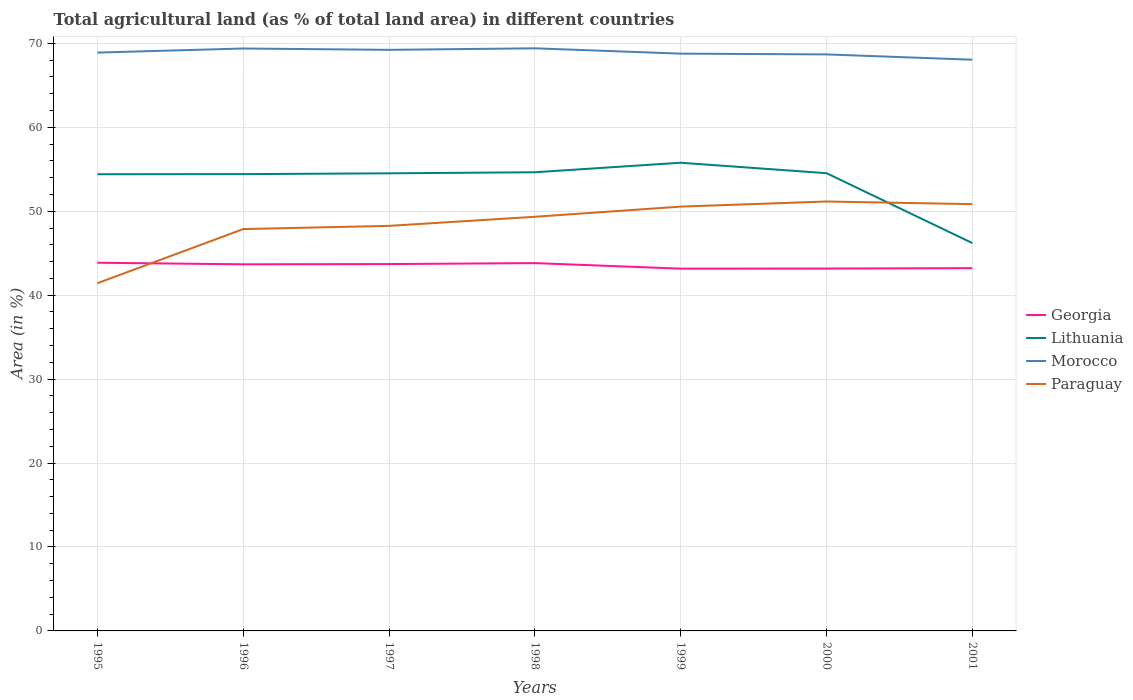How many different coloured lines are there?
Give a very brief answer. 4. Does the line corresponding to Morocco intersect with the line corresponding to Paraguay?
Your response must be concise. No. Is the number of lines equal to the number of legend labels?
Make the answer very short. Yes. Across all years, what is the maximum percentage of agricultural land in Paraguay?
Ensure brevity in your answer.  41.42. What is the total percentage of agricultural land in Paraguay in the graph?
Offer a very short reply. -2.59. What is the difference between the highest and the second highest percentage of agricultural land in Lithuania?
Your answer should be compact. 9.57. What is the difference between the highest and the lowest percentage of agricultural land in Paraguay?
Make the answer very short. 4. Is the percentage of agricultural land in Lithuania strictly greater than the percentage of agricultural land in Morocco over the years?
Your response must be concise. Yes. Does the graph contain any zero values?
Your answer should be very brief. No. What is the title of the graph?
Keep it short and to the point. Total agricultural land (as % of total land area) in different countries. Does "Sub-Saharan Africa (developing only)" appear as one of the legend labels in the graph?
Offer a terse response. No. What is the label or title of the Y-axis?
Offer a very short reply. Area (in %). What is the Area (in %) of Georgia in 1995?
Provide a short and direct response. 43.86. What is the Area (in %) of Lithuania in 1995?
Keep it short and to the point. 54.4. What is the Area (in %) of Morocco in 1995?
Your response must be concise. 68.9. What is the Area (in %) in Paraguay in 1995?
Make the answer very short. 41.42. What is the Area (in %) in Georgia in 1996?
Offer a terse response. 43.68. What is the Area (in %) in Lithuania in 1996?
Offer a terse response. 54.42. What is the Area (in %) of Morocco in 1996?
Your answer should be compact. 69.38. What is the Area (in %) of Paraguay in 1996?
Make the answer very short. 47.88. What is the Area (in %) of Georgia in 1997?
Provide a short and direct response. 43.7. What is the Area (in %) of Lithuania in 1997?
Provide a succinct answer. 54.51. What is the Area (in %) of Morocco in 1997?
Provide a short and direct response. 69.22. What is the Area (in %) in Paraguay in 1997?
Give a very brief answer. 48.25. What is the Area (in %) of Georgia in 1998?
Offer a very short reply. 43.82. What is the Area (in %) in Lithuania in 1998?
Your answer should be very brief. 54.64. What is the Area (in %) in Morocco in 1998?
Provide a succinct answer. 69.41. What is the Area (in %) in Paraguay in 1998?
Offer a terse response. 49.34. What is the Area (in %) of Georgia in 1999?
Keep it short and to the point. 43.16. What is the Area (in %) in Lithuania in 1999?
Provide a succinct answer. 55.78. What is the Area (in %) in Morocco in 1999?
Make the answer very short. 68.77. What is the Area (in %) of Paraguay in 1999?
Provide a succinct answer. 50.55. What is the Area (in %) in Georgia in 2000?
Make the answer very short. 43.17. What is the Area (in %) in Lithuania in 2000?
Your answer should be compact. 54.53. What is the Area (in %) in Morocco in 2000?
Your response must be concise. 68.68. What is the Area (in %) in Paraguay in 2000?
Offer a terse response. 51.16. What is the Area (in %) in Georgia in 2001?
Ensure brevity in your answer.  43.21. What is the Area (in %) of Lithuania in 2001?
Ensure brevity in your answer.  46.2. What is the Area (in %) of Morocco in 2001?
Your response must be concise. 68.05. What is the Area (in %) in Paraguay in 2001?
Make the answer very short. 50.84. Across all years, what is the maximum Area (in %) in Georgia?
Keep it short and to the point. 43.86. Across all years, what is the maximum Area (in %) of Lithuania?
Offer a terse response. 55.78. Across all years, what is the maximum Area (in %) of Morocco?
Your response must be concise. 69.41. Across all years, what is the maximum Area (in %) of Paraguay?
Your answer should be compact. 51.16. Across all years, what is the minimum Area (in %) in Georgia?
Make the answer very short. 43.16. Across all years, what is the minimum Area (in %) of Lithuania?
Your response must be concise. 46.2. Across all years, what is the minimum Area (in %) of Morocco?
Provide a succinct answer. 68.05. Across all years, what is the minimum Area (in %) in Paraguay?
Provide a short and direct response. 41.42. What is the total Area (in %) of Georgia in the graph?
Provide a succinct answer. 304.61. What is the total Area (in %) of Lithuania in the graph?
Offer a terse response. 374.49. What is the total Area (in %) in Morocco in the graph?
Offer a terse response. 482.41. What is the total Area (in %) in Paraguay in the graph?
Keep it short and to the point. 339.44. What is the difference between the Area (in %) in Georgia in 1995 and that in 1996?
Your answer should be very brief. 0.19. What is the difference between the Area (in %) of Lithuania in 1995 and that in 1996?
Your response must be concise. -0.02. What is the difference between the Area (in %) in Morocco in 1995 and that in 1996?
Your response must be concise. -0.49. What is the difference between the Area (in %) of Paraguay in 1995 and that in 1996?
Make the answer very short. -6.45. What is the difference between the Area (in %) in Georgia in 1995 and that in 1997?
Offer a terse response. 0.16. What is the difference between the Area (in %) in Lithuania in 1995 and that in 1997?
Give a very brief answer. -0.11. What is the difference between the Area (in %) of Morocco in 1995 and that in 1997?
Your answer should be compact. -0.33. What is the difference between the Area (in %) in Paraguay in 1995 and that in 1997?
Offer a very short reply. -6.83. What is the difference between the Area (in %) of Georgia in 1995 and that in 1998?
Provide a short and direct response. 0.04. What is the difference between the Area (in %) in Lithuania in 1995 and that in 1998?
Your response must be concise. -0.24. What is the difference between the Area (in %) of Morocco in 1995 and that in 1998?
Your answer should be very brief. -0.51. What is the difference between the Area (in %) in Paraguay in 1995 and that in 1998?
Ensure brevity in your answer.  -7.91. What is the difference between the Area (in %) in Georgia in 1995 and that in 1999?
Your answer should be very brief. 0.71. What is the difference between the Area (in %) in Lithuania in 1995 and that in 1999?
Make the answer very short. -1.37. What is the difference between the Area (in %) of Morocco in 1995 and that in 1999?
Keep it short and to the point. 0.13. What is the difference between the Area (in %) of Paraguay in 1995 and that in 1999?
Your response must be concise. -9.12. What is the difference between the Area (in %) of Georgia in 1995 and that in 2000?
Provide a succinct answer. 0.69. What is the difference between the Area (in %) in Lithuania in 1995 and that in 2000?
Ensure brevity in your answer.  -0.13. What is the difference between the Area (in %) in Morocco in 1995 and that in 2000?
Give a very brief answer. 0.22. What is the difference between the Area (in %) in Paraguay in 1995 and that in 2000?
Offer a terse response. -9.73. What is the difference between the Area (in %) in Georgia in 1995 and that in 2001?
Your response must be concise. 0.65. What is the difference between the Area (in %) in Lithuania in 1995 and that in 2001?
Your answer should be compact. 8.2. What is the difference between the Area (in %) of Morocco in 1995 and that in 2001?
Your answer should be compact. 0.85. What is the difference between the Area (in %) in Paraguay in 1995 and that in 2001?
Ensure brevity in your answer.  -9.42. What is the difference between the Area (in %) of Georgia in 1996 and that in 1997?
Your response must be concise. -0.03. What is the difference between the Area (in %) in Lithuania in 1996 and that in 1997?
Provide a short and direct response. -0.1. What is the difference between the Area (in %) in Morocco in 1996 and that in 1997?
Make the answer very short. 0.16. What is the difference between the Area (in %) in Paraguay in 1996 and that in 1997?
Provide a succinct answer. -0.38. What is the difference between the Area (in %) of Georgia in 1996 and that in 1998?
Your answer should be compact. -0.14. What is the difference between the Area (in %) of Lithuania in 1996 and that in 1998?
Your response must be concise. -0.22. What is the difference between the Area (in %) in Morocco in 1996 and that in 1998?
Offer a terse response. -0.02. What is the difference between the Area (in %) of Paraguay in 1996 and that in 1998?
Give a very brief answer. -1.46. What is the difference between the Area (in %) in Georgia in 1996 and that in 1999?
Your response must be concise. 0.52. What is the difference between the Area (in %) in Lithuania in 1996 and that in 1999?
Offer a very short reply. -1.36. What is the difference between the Area (in %) of Morocco in 1996 and that in 1999?
Ensure brevity in your answer.  0.61. What is the difference between the Area (in %) in Paraguay in 1996 and that in 1999?
Keep it short and to the point. -2.67. What is the difference between the Area (in %) in Georgia in 1996 and that in 2000?
Offer a very short reply. 0.5. What is the difference between the Area (in %) of Lithuania in 1996 and that in 2000?
Provide a succinct answer. -0.11. What is the difference between the Area (in %) of Morocco in 1996 and that in 2000?
Provide a succinct answer. 0.7. What is the difference between the Area (in %) in Paraguay in 1996 and that in 2000?
Offer a very short reply. -3.28. What is the difference between the Area (in %) in Georgia in 1996 and that in 2001?
Give a very brief answer. 0.46. What is the difference between the Area (in %) in Lithuania in 1996 and that in 2001?
Make the answer very short. 8.22. What is the difference between the Area (in %) of Morocco in 1996 and that in 2001?
Provide a short and direct response. 1.34. What is the difference between the Area (in %) of Paraguay in 1996 and that in 2001?
Give a very brief answer. -2.97. What is the difference between the Area (in %) in Georgia in 1997 and that in 1998?
Your response must be concise. -0.12. What is the difference between the Area (in %) of Lithuania in 1997 and that in 1998?
Your answer should be very brief. -0.13. What is the difference between the Area (in %) of Morocco in 1997 and that in 1998?
Offer a terse response. -0.18. What is the difference between the Area (in %) of Paraguay in 1997 and that in 1998?
Make the answer very short. -1.08. What is the difference between the Area (in %) in Georgia in 1997 and that in 1999?
Provide a short and direct response. 0.55. What is the difference between the Area (in %) in Lithuania in 1997 and that in 1999?
Keep it short and to the point. -1.26. What is the difference between the Area (in %) in Morocco in 1997 and that in 1999?
Your answer should be very brief. 0.45. What is the difference between the Area (in %) of Paraguay in 1997 and that in 1999?
Provide a succinct answer. -2.3. What is the difference between the Area (in %) in Georgia in 1997 and that in 2000?
Your answer should be very brief. 0.53. What is the difference between the Area (in %) of Lithuania in 1997 and that in 2000?
Make the answer very short. -0.02. What is the difference between the Area (in %) in Morocco in 1997 and that in 2000?
Ensure brevity in your answer.  0.54. What is the difference between the Area (in %) in Paraguay in 1997 and that in 2000?
Provide a succinct answer. -2.9. What is the difference between the Area (in %) in Georgia in 1997 and that in 2001?
Your answer should be very brief. 0.49. What is the difference between the Area (in %) of Lithuania in 1997 and that in 2001?
Offer a terse response. 8.31. What is the difference between the Area (in %) of Morocco in 1997 and that in 2001?
Your response must be concise. 1.18. What is the difference between the Area (in %) in Paraguay in 1997 and that in 2001?
Your answer should be compact. -2.59. What is the difference between the Area (in %) of Georgia in 1998 and that in 1999?
Provide a short and direct response. 0.66. What is the difference between the Area (in %) in Lithuania in 1998 and that in 1999?
Provide a succinct answer. -1.13. What is the difference between the Area (in %) in Morocco in 1998 and that in 1999?
Offer a very short reply. 0.63. What is the difference between the Area (in %) of Paraguay in 1998 and that in 1999?
Provide a succinct answer. -1.21. What is the difference between the Area (in %) of Georgia in 1998 and that in 2000?
Keep it short and to the point. 0.65. What is the difference between the Area (in %) in Lithuania in 1998 and that in 2000?
Keep it short and to the point. 0.11. What is the difference between the Area (in %) in Morocco in 1998 and that in 2000?
Make the answer very short. 0.73. What is the difference between the Area (in %) of Paraguay in 1998 and that in 2000?
Make the answer very short. -1.82. What is the difference between the Area (in %) in Georgia in 1998 and that in 2001?
Offer a terse response. 0.6. What is the difference between the Area (in %) in Lithuania in 1998 and that in 2001?
Keep it short and to the point. 8.44. What is the difference between the Area (in %) of Morocco in 1998 and that in 2001?
Your response must be concise. 1.36. What is the difference between the Area (in %) in Paraguay in 1998 and that in 2001?
Provide a succinct answer. -1.51. What is the difference between the Area (in %) of Georgia in 1999 and that in 2000?
Provide a succinct answer. -0.01. What is the difference between the Area (in %) in Lithuania in 1999 and that in 2000?
Provide a short and direct response. 1.24. What is the difference between the Area (in %) in Morocco in 1999 and that in 2000?
Provide a short and direct response. 0.09. What is the difference between the Area (in %) in Paraguay in 1999 and that in 2000?
Give a very brief answer. -0.61. What is the difference between the Area (in %) of Georgia in 1999 and that in 2001?
Offer a terse response. -0.06. What is the difference between the Area (in %) of Lithuania in 1999 and that in 2001?
Keep it short and to the point. 9.57. What is the difference between the Area (in %) in Morocco in 1999 and that in 2001?
Your response must be concise. 0.72. What is the difference between the Area (in %) in Paraguay in 1999 and that in 2001?
Offer a terse response. -0.29. What is the difference between the Area (in %) in Georgia in 2000 and that in 2001?
Your answer should be very brief. -0.04. What is the difference between the Area (in %) of Lithuania in 2000 and that in 2001?
Offer a terse response. 8.33. What is the difference between the Area (in %) of Morocco in 2000 and that in 2001?
Give a very brief answer. 0.63. What is the difference between the Area (in %) of Paraguay in 2000 and that in 2001?
Keep it short and to the point. 0.31. What is the difference between the Area (in %) in Georgia in 1995 and the Area (in %) in Lithuania in 1996?
Offer a very short reply. -10.56. What is the difference between the Area (in %) in Georgia in 1995 and the Area (in %) in Morocco in 1996?
Give a very brief answer. -25.52. What is the difference between the Area (in %) in Georgia in 1995 and the Area (in %) in Paraguay in 1996?
Make the answer very short. -4.01. What is the difference between the Area (in %) in Lithuania in 1995 and the Area (in %) in Morocco in 1996?
Keep it short and to the point. -14.98. What is the difference between the Area (in %) in Lithuania in 1995 and the Area (in %) in Paraguay in 1996?
Offer a very short reply. 6.53. What is the difference between the Area (in %) in Morocco in 1995 and the Area (in %) in Paraguay in 1996?
Your answer should be compact. 21.02. What is the difference between the Area (in %) in Georgia in 1995 and the Area (in %) in Lithuania in 1997?
Make the answer very short. -10.65. What is the difference between the Area (in %) in Georgia in 1995 and the Area (in %) in Morocco in 1997?
Keep it short and to the point. -25.36. What is the difference between the Area (in %) in Georgia in 1995 and the Area (in %) in Paraguay in 1997?
Provide a short and direct response. -4.39. What is the difference between the Area (in %) in Lithuania in 1995 and the Area (in %) in Morocco in 1997?
Provide a succinct answer. -14.82. What is the difference between the Area (in %) of Lithuania in 1995 and the Area (in %) of Paraguay in 1997?
Provide a succinct answer. 6.15. What is the difference between the Area (in %) of Morocco in 1995 and the Area (in %) of Paraguay in 1997?
Provide a succinct answer. 20.64. What is the difference between the Area (in %) of Georgia in 1995 and the Area (in %) of Lithuania in 1998?
Offer a very short reply. -10.78. What is the difference between the Area (in %) in Georgia in 1995 and the Area (in %) in Morocco in 1998?
Your answer should be compact. -25.54. What is the difference between the Area (in %) of Georgia in 1995 and the Area (in %) of Paraguay in 1998?
Provide a short and direct response. -5.48. What is the difference between the Area (in %) in Lithuania in 1995 and the Area (in %) in Morocco in 1998?
Offer a terse response. -15. What is the difference between the Area (in %) of Lithuania in 1995 and the Area (in %) of Paraguay in 1998?
Your answer should be very brief. 5.07. What is the difference between the Area (in %) of Morocco in 1995 and the Area (in %) of Paraguay in 1998?
Provide a succinct answer. 19.56. What is the difference between the Area (in %) in Georgia in 1995 and the Area (in %) in Lithuania in 1999?
Provide a succinct answer. -11.91. What is the difference between the Area (in %) in Georgia in 1995 and the Area (in %) in Morocco in 1999?
Your answer should be very brief. -24.91. What is the difference between the Area (in %) of Georgia in 1995 and the Area (in %) of Paraguay in 1999?
Offer a terse response. -6.69. What is the difference between the Area (in %) of Lithuania in 1995 and the Area (in %) of Morocco in 1999?
Your response must be concise. -14.37. What is the difference between the Area (in %) of Lithuania in 1995 and the Area (in %) of Paraguay in 1999?
Keep it short and to the point. 3.85. What is the difference between the Area (in %) in Morocco in 1995 and the Area (in %) in Paraguay in 1999?
Offer a terse response. 18.35. What is the difference between the Area (in %) in Georgia in 1995 and the Area (in %) in Lithuania in 2000?
Provide a short and direct response. -10.67. What is the difference between the Area (in %) of Georgia in 1995 and the Area (in %) of Morocco in 2000?
Make the answer very short. -24.82. What is the difference between the Area (in %) of Georgia in 1995 and the Area (in %) of Paraguay in 2000?
Offer a very short reply. -7.3. What is the difference between the Area (in %) of Lithuania in 1995 and the Area (in %) of Morocco in 2000?
Your response must be concise. -14.28. What is the difference between the Area (in %) in Lithuania in 1995 and the Area (in %) in Paraguay in 2000?
Make the answer very short. 3.25. What is the difference between the Area (in %) of Morocco in 1995 and the Area (in %) of Paraguay in 2000?
Make the answer very short. 17.74. What is the difference between the Area (in %) of Georgia in 1995 and the Area (in %) of Lithuania in 2001?
Give a very brief answer. -2.34. What is the difference between the Area (in %) of Georgia in 1995 and the Area (in %) of Morocco in 2001?
Give a very brief answer. -24.19. What is the difference between the Area (in %) of Georgia in 1995 and the Area (in %) of Paraguay in 2001?
Offer a very short reply. -6.98. What is the difference between the Area (in %) of Lithuania in 1995 and the Area (in %) of Morocco in 2001?
Offer a terse response. -13.65. What is the difference between the Area (in %) in Lithuania in 1995 and the Area (in %) in Paraguay in 2001?
Make the answer very short. 3.56. What is the difference between the Area (in %) in Morocco in 1995 and the Area (in %) in Paraguay in 2001?
Provide a succinct answer. 18.05. What is the difference between the Area (in %) of Georgia in 1996 and the Area (in %) of Lithuania in 1997?
Provide a short and direct response. -10.84. What is the difference between the Area (in %) in Georgia in 1996 and the Area (in %) in Morocco in 1997?
Your answer should be compact. -25.55. What is the difference between the Area (in %) in Georgia in 1996 and the Area (in %) in Paraguay in 1997?
Give a very brief answer. -4.58. What is the difference between the Area (in %) in Lithuania in 1996 and the Area (in %) in Morocco in 1997?
Offer a very short reply. -14.81. What is the difference between the Area (in %) in Lithuania in 1996 and the Area (in %) in Paraguay in 1997?
Provide a short and direct response. 6.17. What is the difference between the Area (in %) of Morocco in 1996 and the Area (in %) of Paraguay in 1997?
Your response must be concise. 21.13. What is the difference between the Area (in %) in Georgia in 1996 and the Area (in %) in Lithuania in 1998?
Offer a terse response. -10.97. What is the difference between the Area (in %) in Georgia in 1996 and the Area (in %) in Morocco in 1998?
Ensure brevity in your answer.  -25.73. What is the difference between the Area (in %) of Georgia in 1996 and the Area (in %) of Paraguay in 1998?
Make the answer very short. -5.66. What is the difference between the Area (in %) in Lithuania in 1996 and the Area (in %) in Morocco in 1998?
Provide a short and direct response. -14.99. What is the difference between the Area (in %) of Lithuania in 1996 and the Area (in %) of Paraguay in 1998?
Offer a terse response. 5.08. What is the difference between the Area (in %) in Morocco in 1996 and the Area (in %) in Paraguay in 1998?
Your response must be concise. 20.05. What is the difference between the Area (in %) in Georgia in 1996 and the Area (in %) in Lithuania in 1999?
Your answer should be compact. -12.1. What is the difference between the Area (in %) of Georgia in 1996 and the Area (in %) of Morocco in 1999?
Give a very brief answer. -25.1. What is the difference between the Area (in %) of Georgia in 1996 and the Area (in %) of Paraguay in 1999?
Ensure brevity in your answer.  -6.87. What is the difference between the Area (in %) in Lithuania in 1996 and the Area (in %) in Morocco in 1999?
Keep it short and to the point. -14.35. What is the difference between the Area (in %) of Lithuania in 1996 and the Area (in %) of Paraguay in 1999?
Provide a succinct answer. 3.87. What is the difference between the Area (in %) of Morocco in 1996 and the Area (in %) of Paraguay in 1999?
Provide a succinct answer. 18.84. What is the difference between the Area (in %) of Georgia in 1996 and the Area (in %) of Lithuania in 2000?
Your response must be concise. -10.86. What is the difference between the Area (in %) in Georgia in 1996 and the Area (in %) in Morocco in 2000?
Keep it short and to the point. -25. What is the difference between the Area (in %) in Georgia in 1996 and the Area (in %) in Paraguay in 2000?
Provide a succinct answer. -7.48. What is the difference between the Area (in %) in Lithuania in 1996 and the Area (in %) in Morocco in 2000?
Keep it short and to the point. -14.26. What is the difference between the Area (in %) in Lithuania in 1996 and the Area (in %) in Paraguay in 2000?
Give a very brief answer. 3.26. What is the difference between the Area (in %) in Morocco in 1996 and the Area (in %) in Paraguay in 2000?
Offer a terse response. 18.23. What is the difference between the Area (in %) in Georgia in 1996 and the Area (in %) in Lithuania in 2001?
Offer a terse response. -2.53. What is the difference between the Area (in %) in Georgia in 1996 and the Area (in %) in Morocco in 2001?
Give a very brief answer. -24.37. What is the difference between the Area (in %) in Georgia in 1996 and the Area (in %) in Paraguay in 2001?
Offer a terse response. -7.17. What is the difference between the Area (in %) of Lithuania in 1996 and the Area (in %) of Morocco in 2001?
Keep it short and to the point. -13.63. What is the difference between the Area (in %) of Lithuania in 1996 and the Area (in %) of Paraguay in 2001?
Ensure brevity in your answer.  3.58. What is the difference between the Area (in %) in Morocco in 1996 and the Area (in %) in Paraguay in 2001?
Provide a short and direct response. 18.54. What is the difference between the Area (in %) in Georgia in 1997 and the Area (in %) in Lithuania in 1998?
Give a very brief answer. -10.94. What is the difference between the Area (in %) in Georgia in 1997 and the Area (in %) in Morocco in 1998?
Provide a short and direct response. -25.7. What is the difference between the Area (in %) of Georgia in 1997 and the Area (in %) of Paraguay in 1998?
Keep it short and to the point. -5.63. What is the difference between the Area (in %) of Lithuania in 1997 and the Area (in %) of Morocco in 1998?
Your answer should be very brief. -14.89. What is the difference between the Area (in %) in Lithuania in 1997 and the Area (in %) in Paraguay in 1998?
Your response must be concise. 5.18. What is the difference between the Area (in %) in Morocco in 1997 and the Area (in %) in Paraguay in 1998?
Your answer should be compact. 19.89. What is the difference between the Area (in %) of Georgia in 1997 and the Area (in %) of Lithuania in 1999?
Ensure brevity in your answer.  -12.07. What is the difference between the Area (in %) of Georgia in 1997 and the Area (in %) of Morocco in 1999?
Offer a terse response. -25.07. What is the difference between the Area (in %) of Georgia in 1997 and the Area (in %) of Paraguay in 1999?
Offer a very short reply. -6.84. What is the difference between the Area (in %) in Lithuania in 1997 and the Area (in %) in Morocco in 1999?
Ensure brevity in your answer.  -14.26. What is the difference between the Area (in %) in Lithuania in 1997 and the Area (in %) in Paraguay in 1999?
Your response must be concise. 3.97. What is the difference between the Area (in %) in Morocco in 1997 and the Area (in %) in Paraguay in 1999?
Your answer should be compact. 18.68. What is the difference between the Area (in %) in Georgia in 1997 and the Area (in %) in Lithuania in 2000?
Offer a terse response. -10.83. What is the difference between the Area (in %) of Georgia in 1997 and the Area (in %) of Morocco in 2000?
Offer a very short reply. -24.98. What is the difference between the Area (in %) in Georgia in 1997 and the Area (in %) in Paraguay in 2000?
Keep it short and to the point. -7.45. What is the difference between the Area (in %) in Lithuania in 1997 and the Area (in %) in Morocco in 2000?
Your answer should be compact. -14.17. What is the difference between the Area (in %) of Lithuania in 1997 and the Area (in %) of Paraguay in 2000?
Offer a terse response. 3.36. What is the difference between the Area (in %) in Morocco in 1997 and the Area (in %) in Paraguay in 2000?
Your answer should be compact. 18.07. What is the difference between the Area (in %) of Georgia in 1997 and the Area (in %) of Lithuania in 2001?
Your answer should be compact. -2.5. What is the difference between the Area (in %) of Georgia in 1997 and the Area (in %) of Morocco in 2001?
Offer a very short reply. -24.34. What is the difference between the Area (in %) in Georgia in 1997 and the Area (in %) in Paraguay in 2001?
Your answer should be very brief. -7.14. What is the difference between the Area (in %) in Lithuania in 1997 and the Area (in %) in Morocco in 2001?
Give a very brief answer. -13.53. What is the difference between the Area (in %) of Lithuania in 1997 and the Area (in %) of Paraguay in 2001?
Provide a succinct answer. 3.67. What is the difference between the Area (in %) in Morocco in 1997 and the Area (in %) in Paraguay in 2001?
Give a very brief answer. 18.38. What is the difference between the Area (in %) of Georgia in 1998 and the Area (in %) of Lithuania in 1999?
Make the answer very short. -11.96. What is the difference between the Area (in %) of Georgia in 1998 and the Area (in %) of Morocco in 1999?
Your answer should be compact. -24.95. What is the difference between the Area (in %) of Georgia in 1998 and the Area (in %) of Paraguay in 1999?
Your answer should be compact. -6.73. What is the difference between the Area (in %) in Lithuania in 1998 and the Area (in %) in Morocco in 1999?
Your answer should be compact. -14.13. What is the difference between the Area (in %) in Lithuania in 1998 and the Area (in %) in Paraguay in 1999?
Make the answer very short. 4.09. What is the difference between the Area (in %) of Morocco in 1998 and the Area (in %) of Paraguay in 1999?
Provide a succinct answer. 18.86. What is the difference between the Area (in %) in Georgia in 1998 and the Area (in %) in Lithuania in 2000?
Offer a terse response. -10.71. What is the difference between the Area (in %) of Georgia in 1998 and the Area (in %) of Morocco in 2000?
Provide a short and direct response. -24.86. What is the difference between the Area (in %) in Georgia in 1998 and the Area (in %) in Paraguay in 2000?
Give a very brief answer. -7.34. What is the difference between the Area (in %) of Lithuania in 1998 and the Area (in %) of Morocco in 2000?
Your answer should be compact. -14.04. What is the difference between the Area (in %) of Lithuania in 1998 and the Area (in %) of Paraguay in 2000?
Give a very brief answer. 3.48. What is the difference between the Area (in %) in Morocco in 1998 and the Area (in %) in Paraguay in 2000?
Offer a terse response. 18.25. What is the difference between the Area (in %) in Georgia in 1998 and the Area (in %) in Lithuania in 2001?
Provide a succinct answer. -2.38. What is the difference between the Area (in %) of Georgia in 1998 and the Area (in %) of Morocco in 2001?
Your response must be concise. -24.23. What is the difference between the Area (in %) of Georgia in 1998 and the Area (in %) of Paraguay in 2001?
Make the answer very short. -7.02. What is the difference between the Area (in %) of Lithuania in 1998 and the Area (in %) of Morocco in 2001?
Your response must be concise. -13.41. What is the difference between the Area (in %) of Lithuania in 1998 and the Area (in %) of Paraguay in 2001?
Make the answer very short. 3.8. What is the difference between the Area (in %) in Morocco in 1998 and the Area (in %) in Paraguay in 2001?
Your answer should be compact. 18.56. What is the difference between the Area (in %) in Georgia in 1999 and the Area (in %) in Lithuania in 2000?
Your answer should be compact. -11.37. What is the difference between the Area (in %) of Georgia in 1999 and the Area (in %) of Morocco in 2000?
Ensure brevity in your answer.  -25.52. What is the difference between the Area (in %) in Georgia in 1999 and the Area (in %) in Paraguay in 2000?
Provide a succinct answer. -8. What is the difference between the Area (in %) in Lithuania in 1999 and the Area (in %) in Morocco in 2000?
Keep it short and to the point. -12.9. What is the difference between the Area (in %) of Lithuania in 1999 and the Area (in %) of Paraguay in 2000?
Offer a terse response. 4.62. What is the difference between the Area (in %) in Morocco in 1999 and the Area (in %) in Paraguay in 2000?
Your answer should be very brief. 17.61. What is the difference between the Area (in %) in Georgia in 1999 and the Area (in %) in Lithuania in 2001?
Provide a succinct answer. -3.05. What is the difference between the Area (in %) of Georgia in 1999 and the Area (in %) of Morocco in 2001?
Keep it short and to the point. -24.89. What is the difference between the Area (in %) in Georgia in 1999 and the Area (in %) in Paraguay in 2001?
Your answer should be very brief. -7.69. What is the difference between the Area (in %) in Lithuania in 1999 and the Area (in %) in Morocco in 2001?
Provide a succinct answer. -12.27. What is the difference between the Area (in %) in Lithuania in 1999 and the Area (in %) in Paraguay in 2001?
Your response must be concise. 4.93. What is the difference between the Area (in %) in Morocco in 1999 and the Area (in %) in Paraguay in 2001?
Your answer should be very brief. 17.93. What is the difference between the Area (in %) in Georgia in 2000 and the Area (in %) in Lithuania in 2001?
Give a very brief answer. -3.03. What is the difference between the Area (in %) of Georgia in 2000 and the Area (in %) of Morocco in 2001?
Keep it short and to the point. -24.88. What is the difference between the Area (in %) of Georgia in 2000 and the Area (in %) of Paraguay in 2001?
Ensure brevity in your answer.  -7.67. What is the difference between the Area (in %) of Lithuania in 2000 and the Area (in %) of Morocco in 2001?
Your answer should be compact. -13.52. What is the difference between the Area (in %) in Lithuania in 2000 and the Area (in %) in Paraguay in 2001?
Make the answer very short. 3.69. What is the difference between the Area (in %) of Morocco in 2000 and the Area (in %) of Paraguay in 2001?
Provide a short and direct response. 17.84. What is the average Area (in %) in Georgia per year?
Offer a very short reply. 43.52. What is the average Area (in %) in Lithuania per year?
Your answer should be very brief. 53.5. What is the average Area (in %) of Morocco per year?
Ensure brevity in your answer.  68.92. What is the average Area (in %) of Paraguay per year?
Provide a succinct answer. 48.49. In the year 1995, what is the difference between the Area (in %) of Georgia and Area (in %) of Lithuania?
Provide a short and direct response. -10.54. In the year 1995, what is the difference between the Area (in %) of Georgia and Area (in %) of Morocco?
Make the answer very short. -25.04. In the year 1995, what is the difference between the Area (in %) in Georgia and Area (in %) in Paraguay?
Your response must be concise. 2.44. In the year 1995, what is the difference between the Area (in %) of Lithuania and Area (in %) of Morocco?
Provide a short and direct response. -14.49. In the year 1995, what is the difference between the Area (in %) in Lithuania and Area (in %) in Paraguay?
Give a very brief answer. 12.98. In the year 1995, what is the difference between the Area (in %) in Morocco and Area (in %) in Paraguay?
Offer a terse response. 27.47. In the year 1996, what is the difference between the Area (in %) in Georgia and Area (in %) in Lithuania?
Offer a terse response. -10.74. In the year 1996, what is the difference between the Area (in %) in Georgia and Area (in %) in Morocco?
Provide a short and direct response. -25.71. In the year 1996, what is the difference between the Area (in %) of Georgia and Area (in %) of Paraguay?
Provide a short and direct response. -4.2. In the year 1996, what is the difference between the Area (in %) in Lithuania and Area (in %) in Morocco?
Your answer should be compact. -14.96. In the year 1996, what is the difference between the Area (in %) in Lithuania and Area (in %) in Paraguay?
Your answer should be very brief. 6.54. In the year 1996, what is the difference between the Area (in %) of Morocco and Area (in %) of Paraguay?
Offer a very short reply. 21.51. In the year 1997, what is the difference between the Area (in %) of Georgia and Area (in %) of Lithuania?
Your answer should be compact. -10.81. In the year 1997, what is the difference between the Area (in %) of Georgia and Area (in %) of Morocco?
Your answer should be very brief. -25.52. In the year 1997, what is the difference between the Area (in %) in Georgia and Area (in %) in Paraguay?
Offer a terse response. -4.55. In the year 1997, what is the difference between the Area (in %) of Lithuania and Area (in %) of Morocco?
Make the answer very short. -14.71. In the year 1997, what is the difference between the Area (in %) in Lithuania and Area (in %) in Paraguay?
Your answer should be compact. 6.26. In the year 1997, what is the difference between the Area (in %) of Morocco and Area (in %) of Paraguay?
Provide a succinct answer. 20.97. In the year 1998, what is the difference between the Area (in %) of Georgia and Area (in %) of Lithuania?
Provide a succinct answer. -10.82. In the year 1998, what is the difference between the Area (in %) in Georgia and Area (in %) in Morocco?
Your answer should be very brief. -25.59. In the year 1998, what is the difference between the Area (in %) of Georgia and Area (in %) of Paraguay?
Make the answer very short. -5.52. In the year 1998, what is the difference between the Area (in %) of Lithuania and Area (in %) of Morocco?
Keep it short and to the point. -14.76. In the year 1998, what is the difference between the Area (in %) of Lithuania and Area (in %) of Paraguay?
Provide a short and direct response. 5.3. In the year 1998, what is the difference between the Area (in %) of Morocco and Area (in %) of Paraguay?
Provide a short and direct response. 20.07. In the year 1999, what is the difference between the Area (in %) of Georgia and Area (in %) of Lithuania?
Offer a very short reply. -12.62. In the year 1999, what is the difference between the Area (in %) of Georgia and Area (in %) of Morocco?
Give a very brief answer. -25.61. In the year 1999, what is the difference between the Area (in %) in Georgia and Area (in %) in Paraguay?
Keep it short and to the point. -7.39. In the year 1999, what is the difference between the Area (in %) in Lithuania and Area (in %) in Morocco?
Give a very brief answer. -13. In the year 1999, what is the difference between the Area (in %) in Lithuania and Area (in %) in Paraguay?
Offer a terse response. 5.23. In the year 1999, what is the difference between the Area (in %) of Morocco and Area (in %) of Paraguay?
Offer a very short reply. 18.22. In the year 2000, what is the difference between the Area (in %) in Georgia and Area (in %) in Lithuania?
Provide a short and direct response. -11.36. In the year 2000, what is the difference between the Area (in %) of Georgia and Area (in %) of Morocco?
Ensure brevity in your answer.  -25.51. In the year 2000, what is the difference between the Area (in %) of Georgia and Area (in %) of Paraguay?
Provide a succinct answer. -7.99. In the year 2000, what is the difference between the Area (in %) in Lithuania and Area (in %) in Morocco?
Your answer should be compact. -14.15. In the year 2000, what is the difference between the Area (in %) in Lithuania and Area (in %) in Paraguay?
Keep it short and to the point. 3.37. In the year 2000, what is the difference between the Area (in %) in Morocco and Area (in %) in Paraguay?
Ensure brevity in your answer.  17.52. In the year 2001, what is the difference between the Area (in %) of Georgia and Area (in %) of Lithuania?
Give a very brief answer. -2.99. In the year 2001, what is the difference between the Area (in %) in Georgia and Area (in %) in Morocco?
Your answer should be compact. -24.83. In the year 2001, what is the difference between the Area (in %) in Georgia and Area (in %) in Paraguay?
Your response must be concise. -7.63. In the year 2001, what is the difference between the Area (in %) of Lithuania and Area (in %) of Morocco?
Offer a terse response. -21.85. In the year 2001, what is the difference between the Area (in %) of Lithuania and Area (in %) of Paraguay?
Ensure brevity in your answer.  -4.64. In the year 2001, what is the difference between the Area (in %) of Morocco and Area (in %) of Paraguay?
Your answer should be compact. 17.21. What is the ratio of the Area (in %) of Paraguay in 1995 to that in 1996?
Ensure brevity in your answer.  0.87. What is the ratio of the Area (in %) in Georgia in 1995 to that in 1997?
Make the answer very short. 1. What is the ratio of the Area (in %) of Morocco in 1995 to that in 1997?
Provide a short and direct response. 1. What is the ratio of the Area (in %) in Paraguay in 1995 to that in 1997?
Offer a terse response. 0.86. What is the ratio of the Area (in %) in Georgia in 1995 to that in 1998?
Ensure brevity in your answer.  1. What is the ratio of the Area (in %) of Morocco in 1995 to that in 1998?
Your response must be concise. 0.99. What is the ratio of the Area (in %) of Paraguay in 1995 to that in 1998?
Give a very brief answer. 0.84. What is the ratio of the Area (in %) of Georgia in 1995 to that in 1999?
Your response must be concise. 1.02. What is the ratio of the Area (in %) of Lithuania in 1995 to that in 1999?
Provide a succinct answer. 0.98. What is the ratio of the Area (in %) in Paraguay in 1995 to that in 1999?
Keep it short and to the point. 0.82. What is the ratio of the Area (in %) of Lithuania in 1995 to that in 2000?
Keep it short and to the point. 1. What is the ratio of the Area (in %) in Morocco in 1995 to that in 2000?
Provide a short and direct response. 1. What is the ratio of the Area (in %) of Paraguay in 1995 to that in 2000?
Provide a succinct answer. 0.81. What is the ratio of the Area (in %) in Georgia in 1995 to that in 2001?
Offer a very short reply. 1.01. What is the ratio of the Area (in %) in Lithuania in 1995 to that in 2001?
Provide a short and direct response. 1.18. What is the ratio of the Area (in %) in Morocco in 1995 to that in 2001?
Keep it short and to the point. 1.01. What is the ratio of the Area (in %) of Paraguay in 1995 to that in 2001?
Your answer should be very brief. 0.81. What is the ratio of the Area (in %) of Lithuania in 1996 to that in 1997?
Ensure brevity in your answer.  1. What is the ratio of the Area (in %) of Morocco in 1996 to that in 1998?
Keep it short and to the point. 1. What is the ratio of the Area (in %) of Paraguay in 1996 to that in 1998?
Offer a terse response. 0.97. What is the ratio of the Area (in %) of Georgia in 1996 to that in 1999?
Offer a terse response. 1.01. What is the ratio of the Area (in %) of Lithuania in 1996 to that in 1999?
Your answer should be compact. 0.98. What is the ratio of the Area (in %) of Morocco in 1996 to that in 1999?
Ensure brevity in your answer.  1.01. What is the ratio of the Area (in %) of Paraguay in 1996 to that in 1999?
Provide a short and direct response. 0.95. What is the ratio of the Area (in %) of Georgia in 1996 to that in 2000?
Make the answer very short. 1.01. What is the ratio of the Area (in %) in Lithuania in 1996 to that in 2000?
Your answer should be very brief. 1. What is the ratio of the Area (in %) of Morocco in 1996 to that in 2000?
Make the answer very short. 1.01. What is the ratio of the Area (in %) in Paraguay in 1996 to that in 2000?
Provide a succinct answer. 0.94. What is the ratio of the Area (in %) in Georgia in 1996 to that in 2001?
Your answer should be very brief. 1.01. What is the ratio of the Area (in %) of Lithuania in 1996 to that in 2001?
Provide a succinct answer. 1.18. What is the ratio of the Area (in %) in Morocco in 1996 to that in 2001?
Keep it short and to the point. 1.02. What is the ratio of the Area (in %) of Paraguay in 1996 to that in 2001?
Give a very brief answer. 0.94. What is the ratio of the Area (in %) in Georgia in 1997 to that in 1999?
Your answer should be compact. 1.01. What is the ratio of the Area (in %) of Lithuania in 1997 to that in 1999?
Your answer should be very brief. 0.98. What is the ratio of the Area (in %) of Morocco in 1997 to that in 1999?
Offer a very short reply. 1.01. What is the ratio of the Area (in %) in Paraguay in 1997 to that in 1999?
Give a very brief answer. 0.95. What is the ratio of the Area (in %) in Georgia in 1997 to that in 2000?
Your answer should be compact. 1.01. What is the ratio of the Area (in %) in Lithuania in 1997 to that in 2000?
Ensure brevity in your answer.  1. What is the ratio of the Area (in %) in Morocco in 1997 to that in 2000?
Your response must be concise. 1.01. What is the ratio of the Area (in %) of Paraguay in 1997 to that in 2000?
Provide a succinct answer. 0.94. What is the ratio of the Area (in %) in Georgia in 1997 to that in 2001?
Make the answer very short. 1.01. What is the ratio of the Area (in %) of Lithuania in 1997 to that in 2001?
Ensure brevity in your answer.  1.18. What is the ratio of the Area (in %) in Morocco in 1997 to that in 2001?
Your answer should be very brief. 1.02. What is the ratio of the Area (in %) of Paraguay in 1997 to that in 2001?
Provide a succinct answer. 0.95. What is the ratio of the Area (in %) of Georgia in 1998 to that in 1999?
Provide a short and direct response. 1.02. What is the ratio of the Area (in %) of Lithuania in 1998 to that in 1999?
Your answer should be compact. 0.98. What is the ratio of the Area (in %) in Morocco in 1998 to that in 1999?
Give a very brief answer. 1.01. What is the ratio of the Area (in %) of Paraguay in 1998 to that in 1999?
Make the answer very short. 0.98. What is the ratio of the Area (in %) of Georgia in 1998 to that in 2000?
Keep it short and to the point. 1.01. What is the ratio of the Area (in %) of Morocco in 1998 to that in 2000?
Keep it short and to the point. 1.01. What is the ratio of the Area (in %) in Paraguay in 1998 to that in 2000?
Keep it short and to the point. 0.96. What is the ratio of the Area (in %) of Lithuania in 1998 to that in 2001?
Your answer should be very brief. 1.18. What is the ratio of the Area (in %) in Paraguay in 1998 to that in 2001?
Make the answer very short. 0.97. What is the ratio of the Area (in %) of Georgia in 1999 to that in 2000?
Offer a terse response. 1. What is the ratio of the Area (in %) of Lithuania in 1999 to that in 2000?
Your answer should be compact. 1.02. What is the ratio of the Area (in %) in Lithuania in 1999 to that in 2001?
Ensure brevity in your answer.  1.21. What is the ratio of the Area (in %) in Morocco in 1999 to that in 2001?
Give a very brief answer. 1.01. What is the ratio of the Area (in %) of Lithuania in 2000 to that in 2001?
Provide a short and direct response. 1.18. What is the ratio of the Area (in %) of Morocco in 2000 to that in 2001?
Keep it short and to the point. 1.01. What is the ratio of the Area (in %) in Paraguay in 2000 to that in 2001?
Your response must be concise. 1.01. What is the difference between the highest and the second highest Area (in %) of Georgia?
Provide a short and direct response. 0.04. What is the difference between the highest and the second highest Area (in %) of Lithuania?
Make the answer very short. 1.13. What is the difference between the highest and the second highest Area (in %) in Morocco?
Make the answer very short. 0.02. What is the difference between the highest and the second highest Area (in %) of Paraguay?
Offer a terse response. 0.31. What is the difference between the highest and the lowest Area (in %) in Georgia?
Offer a terse response. 0.71. What is the difference between the highest and the lowest Area (in %) in Lithuania?
Offer a terse response. 9.57. What is the difference between the highest and the lowest Area (in %) in Morocco?
Offer a very short reply. 1.36. What is the difference between the highest and the lowest Area (in %) in Paraguay?
Your answer should be compact. 9.73. 